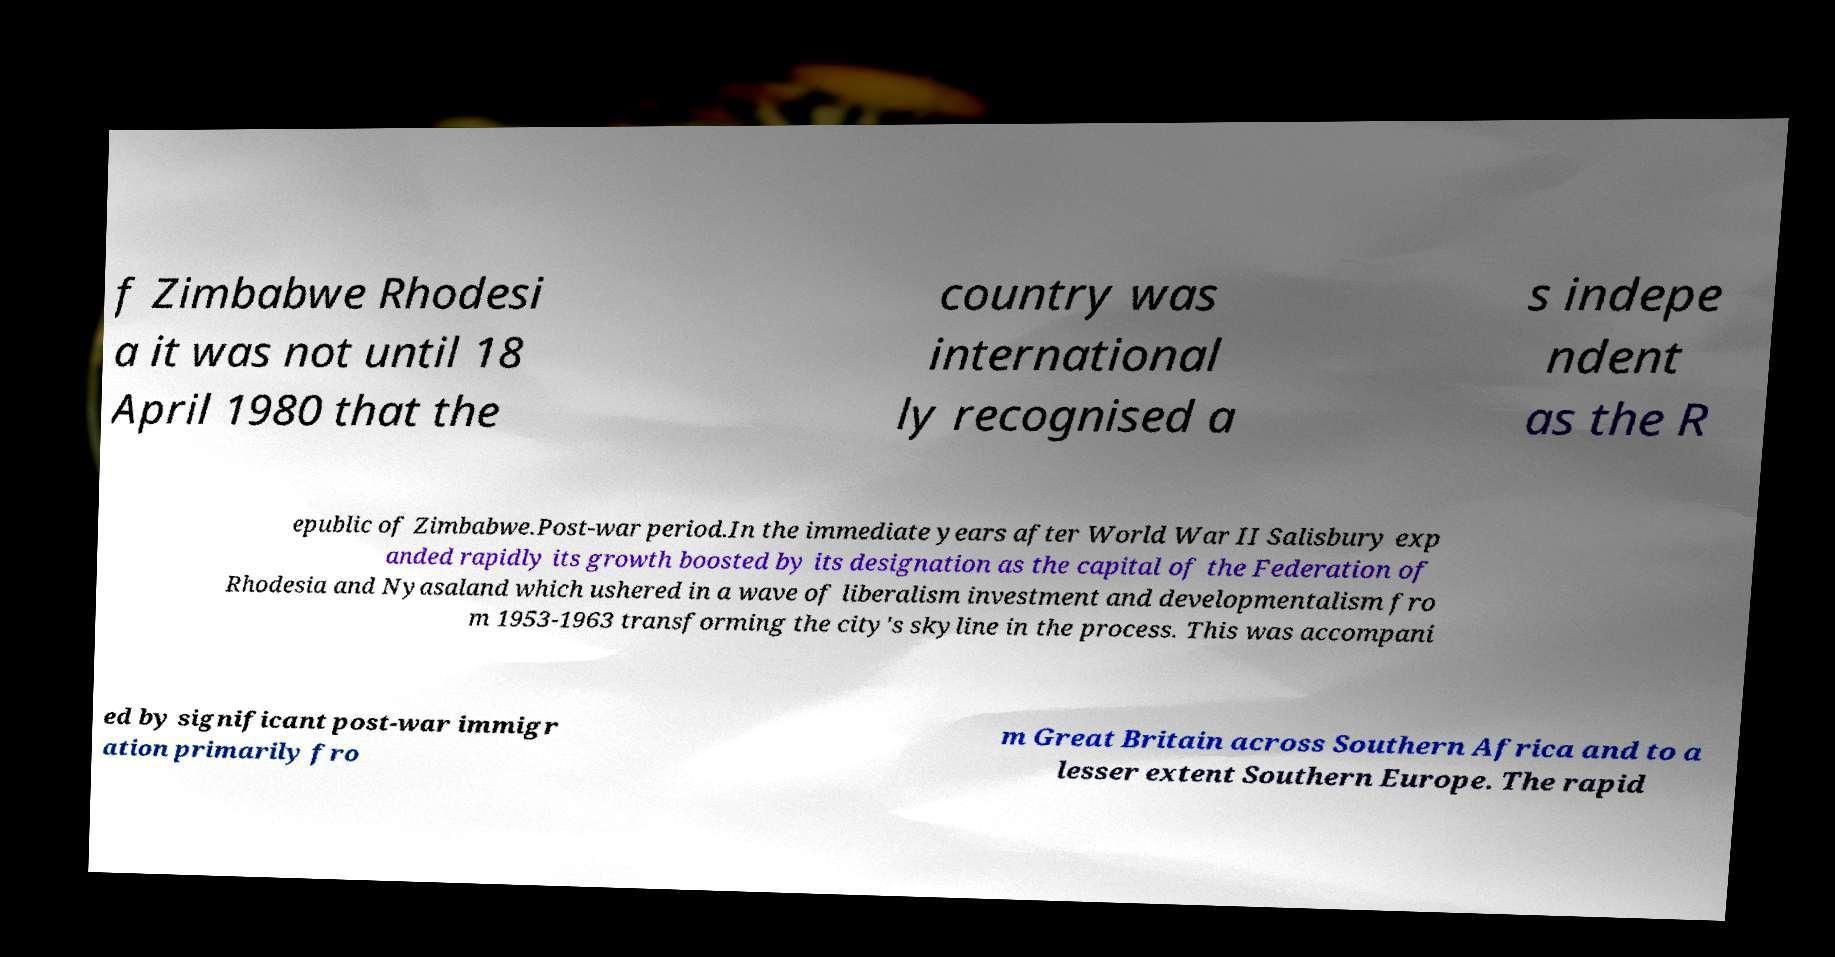For documentation purposes, I need the text within this image transcribed. Could you provide that? f Zimbabwe Rhodesi a it was not until 18 April 1980 that the country was international ly recognised a s indepe ndent as the R epublic of Zimbabwe.Post-war period.In the immediate years after World War II Salisbury exp anded rapidly its growth boosted by its designation as the capital of the Federation of Rhodesia and Nyasaland which ushered in a wave of liberalism investment and developmentalism fro m 1953-1963 transforming the city's skyline in the process. This was accompani ed by significant post-war immigr ation primarily fro m Great Britain across Southern Africa and to a lesser extent Southern Europe. The rapid 